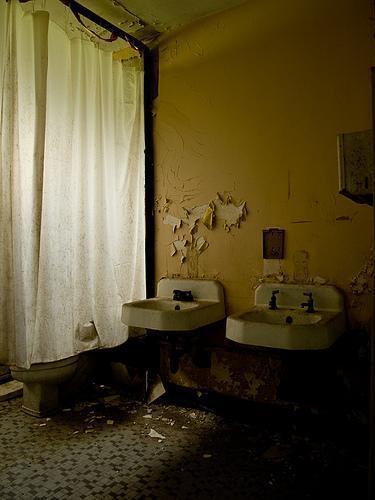How many sinks are there?
Give a very brief answer. 2. 